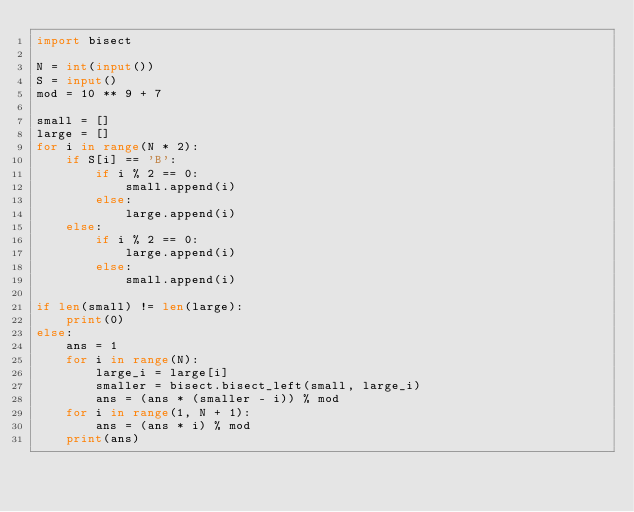Convert code to text. <code><loc_0><loc_0><loc_500><loc_500><_Python_>import bisect

N = int(input())
S = input()
mod = 10 ** 9 + 7

small = []
large = []
for i in range(N * 2):
    if S[i] == 'B':
        if i % 2 == 0:
            small.append(i)
        else:
            large.append(i)
    else:
        if i % 2 == 0:
            large.append(i)
        else:
            small.append(i)

if len(small) != len(large):
    print(0)
else:
    ans = 1
    for i in range(N):
        large_i = large[i]
        smaller = bisect.bisect_left(small, large_i)
        ans = (ans * (smaller - i)) % mod
    for i in range(1, N + 1):
        ans = (ans * i) % mod
    print(ans)
</code> 